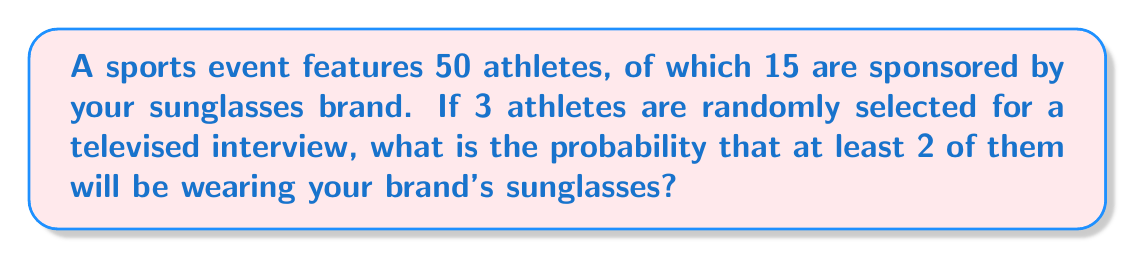Solve this math problem. Let's approach this step-by-step:

1) First, we need to calculate the total number of ways to select 3 athletes out of 50. This is given by the combination formula:

   $$\binom{50}{3} = \frac{50!}{3!(50-3)!} = \frac{50!}{3!47!} = 19,600$$

2) Now, we need to calculate the number of favorable outcomes. We can have two scenarios:
   a) Exactly 2 athletes wearing our brand
   b) All 3 athletes wearing our brand

3) For scenario a):
   - We need to choose 2 out of 15 sponsored athletes: $\binom{15}{2}$
   - And 1 out of the remaining 35 non-sponsored athletes: $\binom{35}{1}$
   
   $$\binom{15}{2} \cdot \binom{35}{1} = 105 \cdot 35 = 3,675$$

4) For scenario b):
   - We need to choose 3 out of 15 sponsored athletes: $\binom{15}{3} = 455$

5) Total favorable outcomes = outcomes from (3) + outcomes from (4)
   
   $3,675 + 455 = 4,130$

6) The probability is then:

   $$P(\text{at least 2 wearing our brand}) = \frac{\text{favorable outcomes}}{\text{total outcomes}} = \frac{4,130}{19,600} = \frac{413}{1,960} \approx 0.2107$$
Answer: $\frac{413}{1,960}$ 